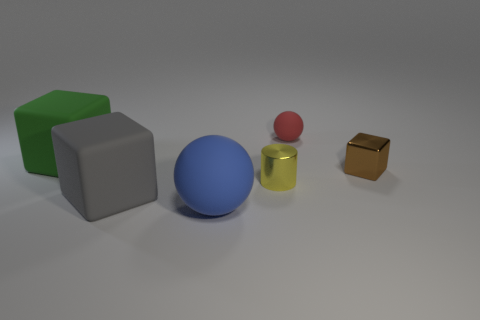Are there any big gray rubber things behind the big matte sphere?
Provide a short and direct response. Yes. Are there more brown cubes in front of the tiny yellow cylinder than big green blocks that are to the right of the gray object?
Make the answer very short. No. What is the size of the gray thing that is the same shape as the brown metallic thing?
Give a very brief answer. Large. How many balls are gray matte things or tiny brown things?
Give a very brief answer. 0. Are there fewer small rubber balls on the left side of the big gray cube than large blue things left of the small brown thing?
Make the answer very short. Yes. What number of objects are either large matte cubes that are right of the green rubber thing or yellow shiny cubes?
Provide a succinct answer. 1. There is a tiny matte object that is to the right of the shiny object that is on the left side of the small red sphere; what is its shape?
Your response must be concise. Sphere. Is there a cyan matte sphere that has the same size as the green object?
Your response must be concise. No. Is the number of small green rubber blocks greater than the number of large blue balls?
Your answer should be very brief. No. Is the size of the thing that is right of the small red sphere the same as the matte ball behind the gray block?
Your answer should be very brief. Yes. 